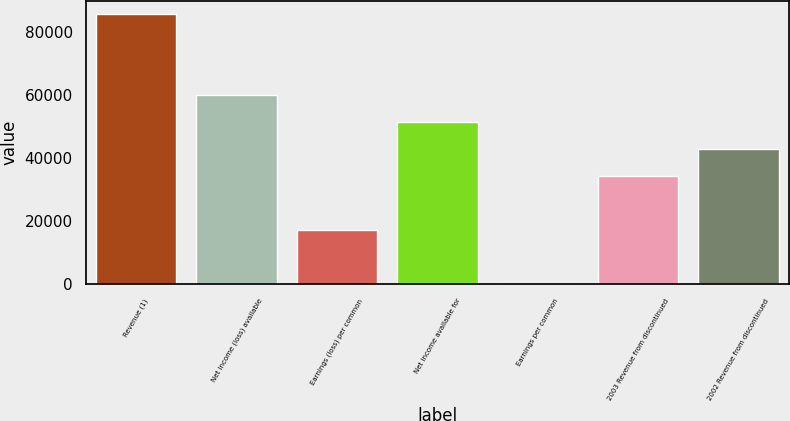Convert chart. <chart><loc_0><loc_0><loc_500><loc_500><bar_chart><fcel>Revenue (1)<fcel>Net income (loss) available<fcel>Earnings (loss) per common<fcel>Net income available for<fcel>Earnings per common<fcel>2003 Revenue from discontinued<fcel>2002 Revenue from discontinued<nl><fcel>85836<fcel>60085.3<fcel>17167.5<fcel>51501.7<fcel>0.31<fcel>34334.6<fcel>42918.2<nl></chart> 